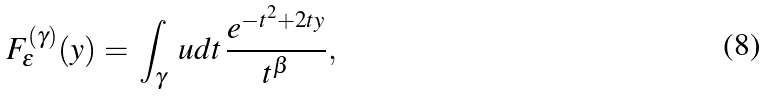Convert formula to latex. <formula><loc_0><loc_0><loc_500><loc_500>F ^ { ( \gamma ) } _ { \epsilon } ( y ) = \, \int _ { \gamma } \ u d t \, \frac { e ^ { - t ^ { 2 } + 2 t y } } { t ^ { \beta } } ,</formula> 